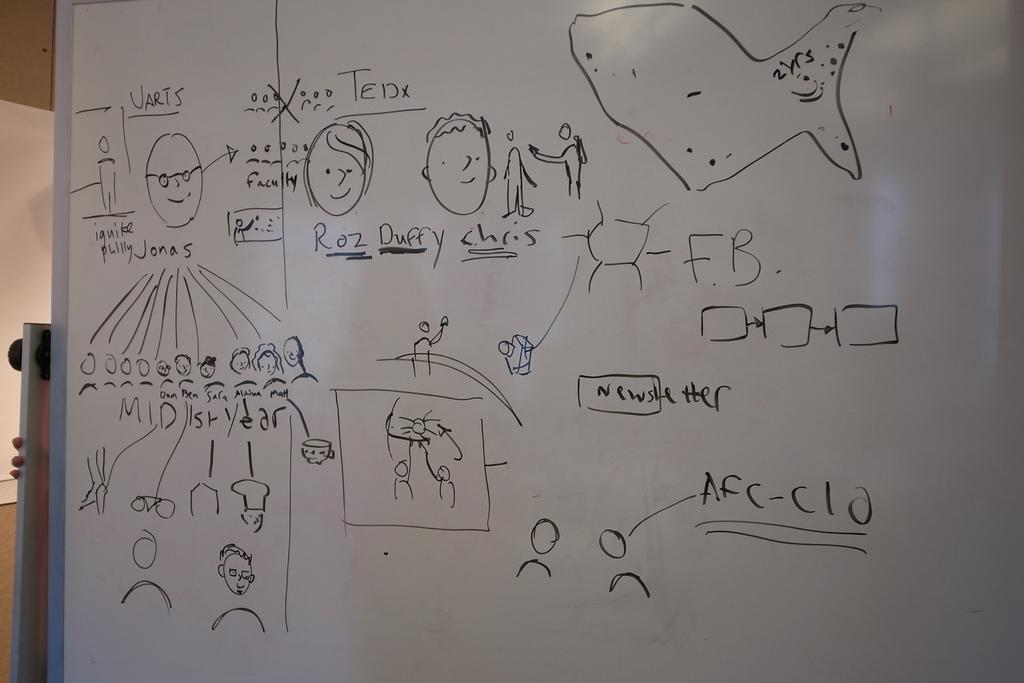What is on the whiteboard in the image? There are drawings and words on the whiteboard in the image. Can you describe the drawings on the whiteboard? Unfortunately, the details of the drawings cannot be determined from the image. What is the person in the background of the image doing? The person is holding a board in the image. What type of air can be seen coming out of the person's nose in the image? There is no person's nose visible in the image, and therefore no air coming out of it can be observed. 